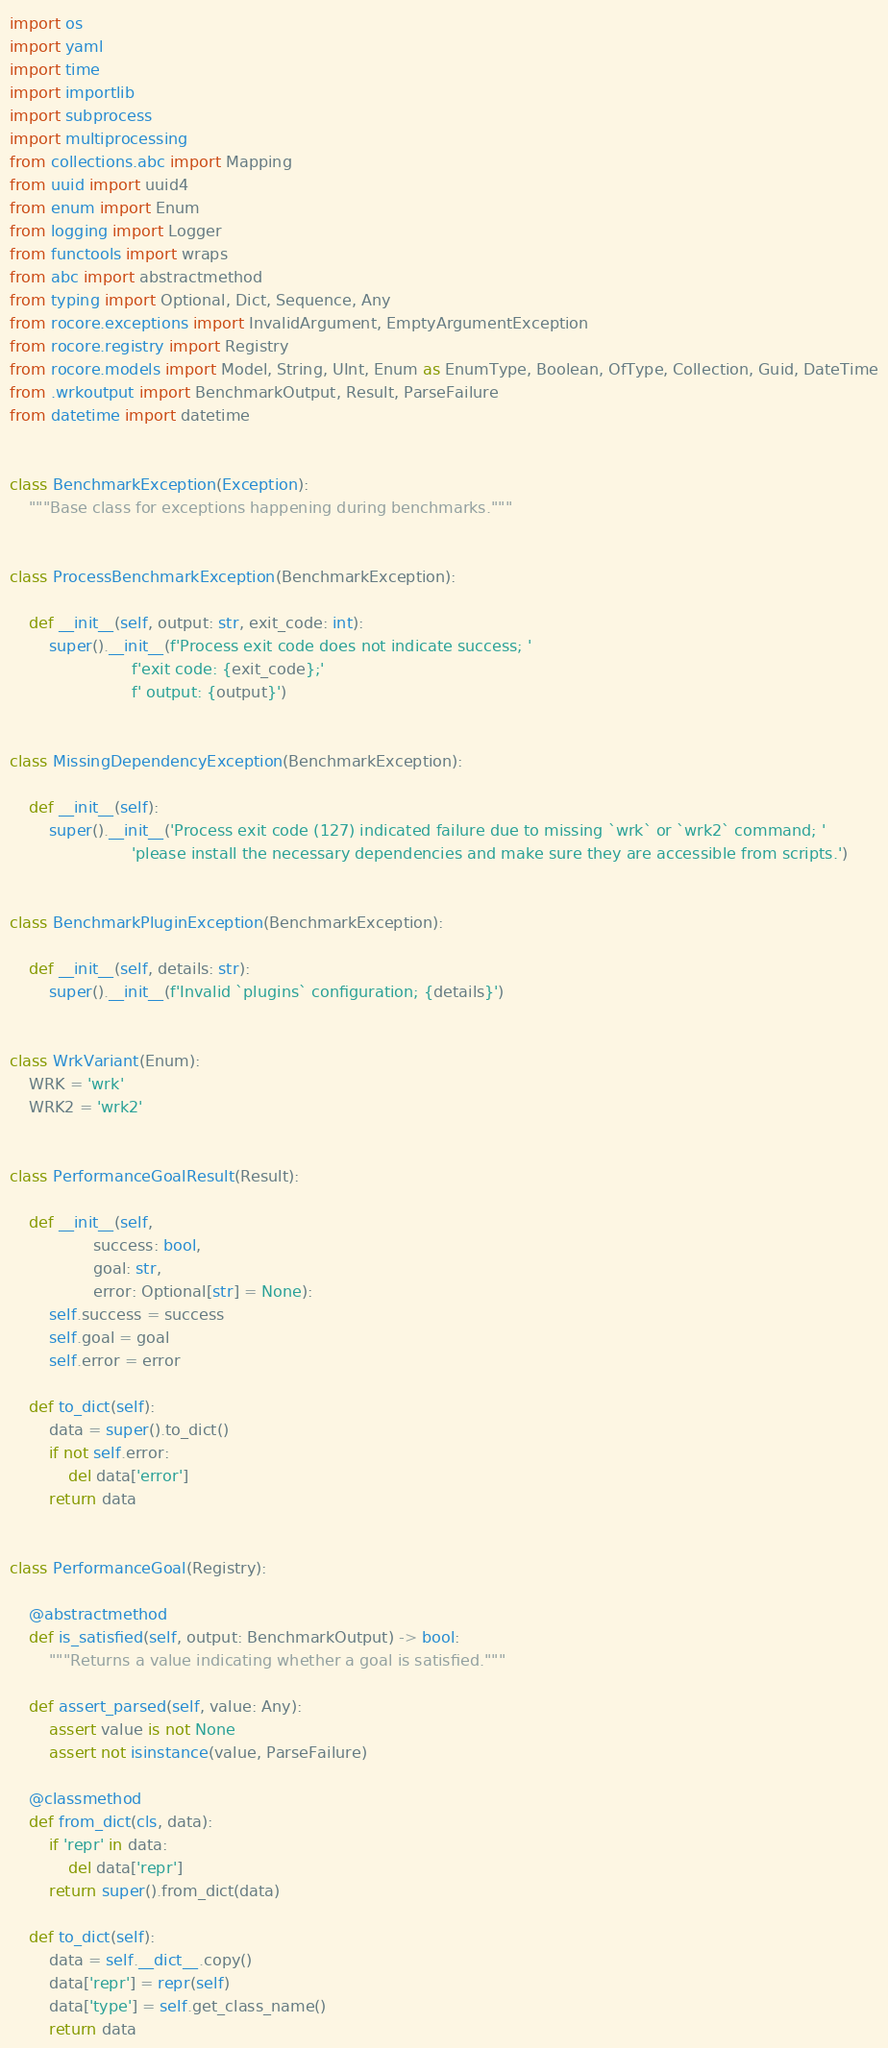Convert code to text. <code><loc_0><loc_0><loc_500><loc_500><_Python_>import os
import yaml
import time
import importlib
import subprocess
import multiprocessing
from collections.abc import Mapping
from uuid import uuid4
from enum import Enum
from logging import Logger
from functools import wraps
from abc import abstractmethod
from typing import Optional, Dict, Sequence, Any
from rocore.exceptions import InvalidArgument, EmptyArgumentException
from rocore.registry import Registry
from rocore.models import Model, String, UInt, Enum as EnumType, Boolean, OfType, Collection, Guid, DateTime
from .wrkoutput import BenchmarkOutput, Result, ParseFailure
from datetime import datetime


class BenchmarkException(Exception):
    """Base class for exceptions happening during benchmarks."""


class ProcessBenchmarkException(BenchmarkException):

    def __init__(self, output: str, exit_code: int):
        super().__init__(f'Process exit code does not indicate success; '
                         f'exit code: {exit_code};'
                         f' output: {output}')


class MissingDependencyException(BenchmarkException):

    def __init__(self):
        super().__init__('Process exit code (127) indicated failure due to missing `wrk` or `wrk2` command; '
                         'please install the necessary dependencies and make sure they are accessible from scripts.')


class BenchmarkPluginException(BenchmarkException):

    def __init__(self, details: str):
        super().__init__(f'Invalid `plugins` configuration; {details}')


class WrkVariant(Enum):
    WRK = 'wrk'
    WRK2 = 'wrk2'


class PerformanceGoalResult(Result):

    def __init__(self,
                 success: bool,
                 goal: str,
                 error: Optional[str] = None):
        self.success = success
        self.goal = goal
        self.error = error

    def to_dict(self):
        data = super().to_dict()
        if not self.error:
            del data['error']
        return data


class PerformanceGoal(Registry):

    @abstractmethod
    def is_satisfied(self, output: BenchmarkOutput) -> bool:
        """Returns a value indicating whether a goal is satisfied."""

    def assert_parsed(self, value: Any):
        assert value is not None
        assert not isinstance(value, ParseFailure)

    @classmethod
    def from_dict(cls, data):
        if 'repr' in data:
            del data['repr']
        return super().from_dict(data)

    def to_dict(self):
        data = self.__dict__.copy()
        data['repr'] = repr(self)
        data['type'] = self.get_class_name()
        return data

</code> 